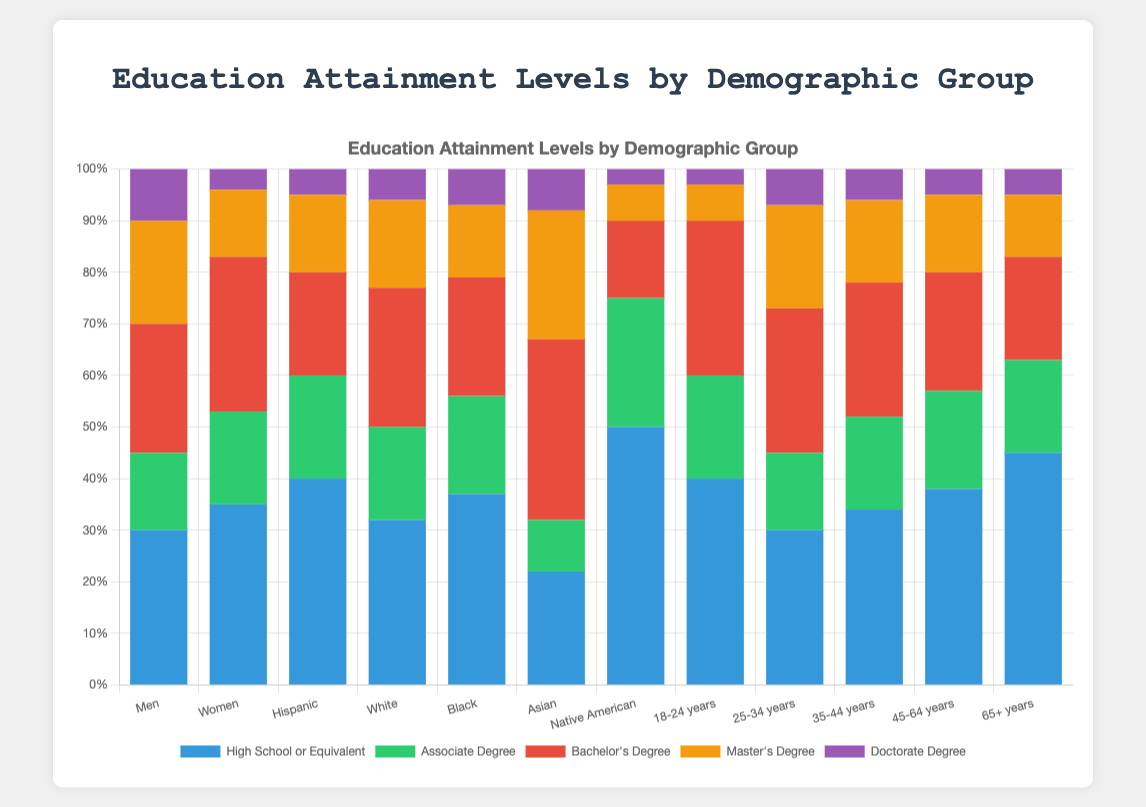Which demographic group has the highest percentage of individuals with a Bachelor's Degree? To determine which demographic group has the highest percentage of individuals with a Bachelor's Degree, look at the height of the bars representing each group for the Bachelor's Degree segment (red). The Asian group has the tallest red bar indicating 35%.
Answer: Asian Which demographic groups have a higher percentage of people with a Master’s Degree compared to a Doctorate Degree? Examine the heights of the segments for both Master’s Degree (orange) and Doctorate Degree (purple) within each bar. Compare the heights, and you will find that Men, Women, Hispanic, White, 25-34 years, and 35-44 years groups have taller orange segments than purple ones.
Answer: Men, Women, Hispanic, White, 25-34 years, 35-44 years What is the total percentage of individuals with at least a Bachelor's Degree in the 18-24 years group? Sum the percentages for Bachelor's Degree, Master's Degree, and Doctorate Degree for the 18-24 years group. Bachelor's Degree (30) + Master's Degree (7) + Doctorate Degree (3) = 40%.
Answer: 40% Which demographic group has the lowest percentage of individuals with a High School or Equivalent level of education? Identify the shortest blue segment representing High School or Equivalent for all groups. The Asian group has the shortest blue segment at 22%.
Answer: Asian Compare the percentage of Men and Women with a Doctorate Degree. Which group has a higher percentage and by how much? Identify the percentage of Men (10%) and Women (4%) with a Doctorate Degree by looking at the height of the purple segments. The difference is 10% - 4% = 6%.
Answer: Men by 6% What is the average percentage of individuals with an Associate Degree across all demographic groups? Sum the percentages of individuals with an Associate Degree across all groups and divide by the number of groups. (15 + 18 + 20 + 18 + 19 + 10 + 25 + 20 + 15 + 18 + 19 + 18) / 12 = 195 / 12 = 16.25%.
Answer: 16.25% Which demographic group has the highest combined percentage of individuals with a Bachelor's Degree and a Master's Degree? Identify and sum the percentages for Bachelor's Degree and Master's Degree for each group, then find the highest total. Asians have 35% (Bachelor’s) + 25% (Master’s) = 60%.
Answer: Asian How does the percentage of Hispanic individuals with a Bachelor's Degree compare to that of the White demographic? Look at the red segments representing Bachelor's Degree for Hispanic (20%) and White (27%) demographics, and compare the heights. The White demographic has 27%, which is higher than the Hispanic demographic at 20%.
Answer: White What percentage of the Native American demographic has a Bachelor's Degree or higher? Sum the percentages for Bachelor's Degree, Master's Degree, and Doctorate Degree for Native Americans. Bachelor's Degree (15) + Master's Degree (7) + Doctorate Degree (3) = 25%.
Answer: 25% Which age group has the highest percentage of individuals with only a High School or Equivalent level of education? Identify the tallest blue segment representing High School or Equivalent for the age groups. The 65+ years group has the tallest blue segment at 45%.
Answer: 65+ years 